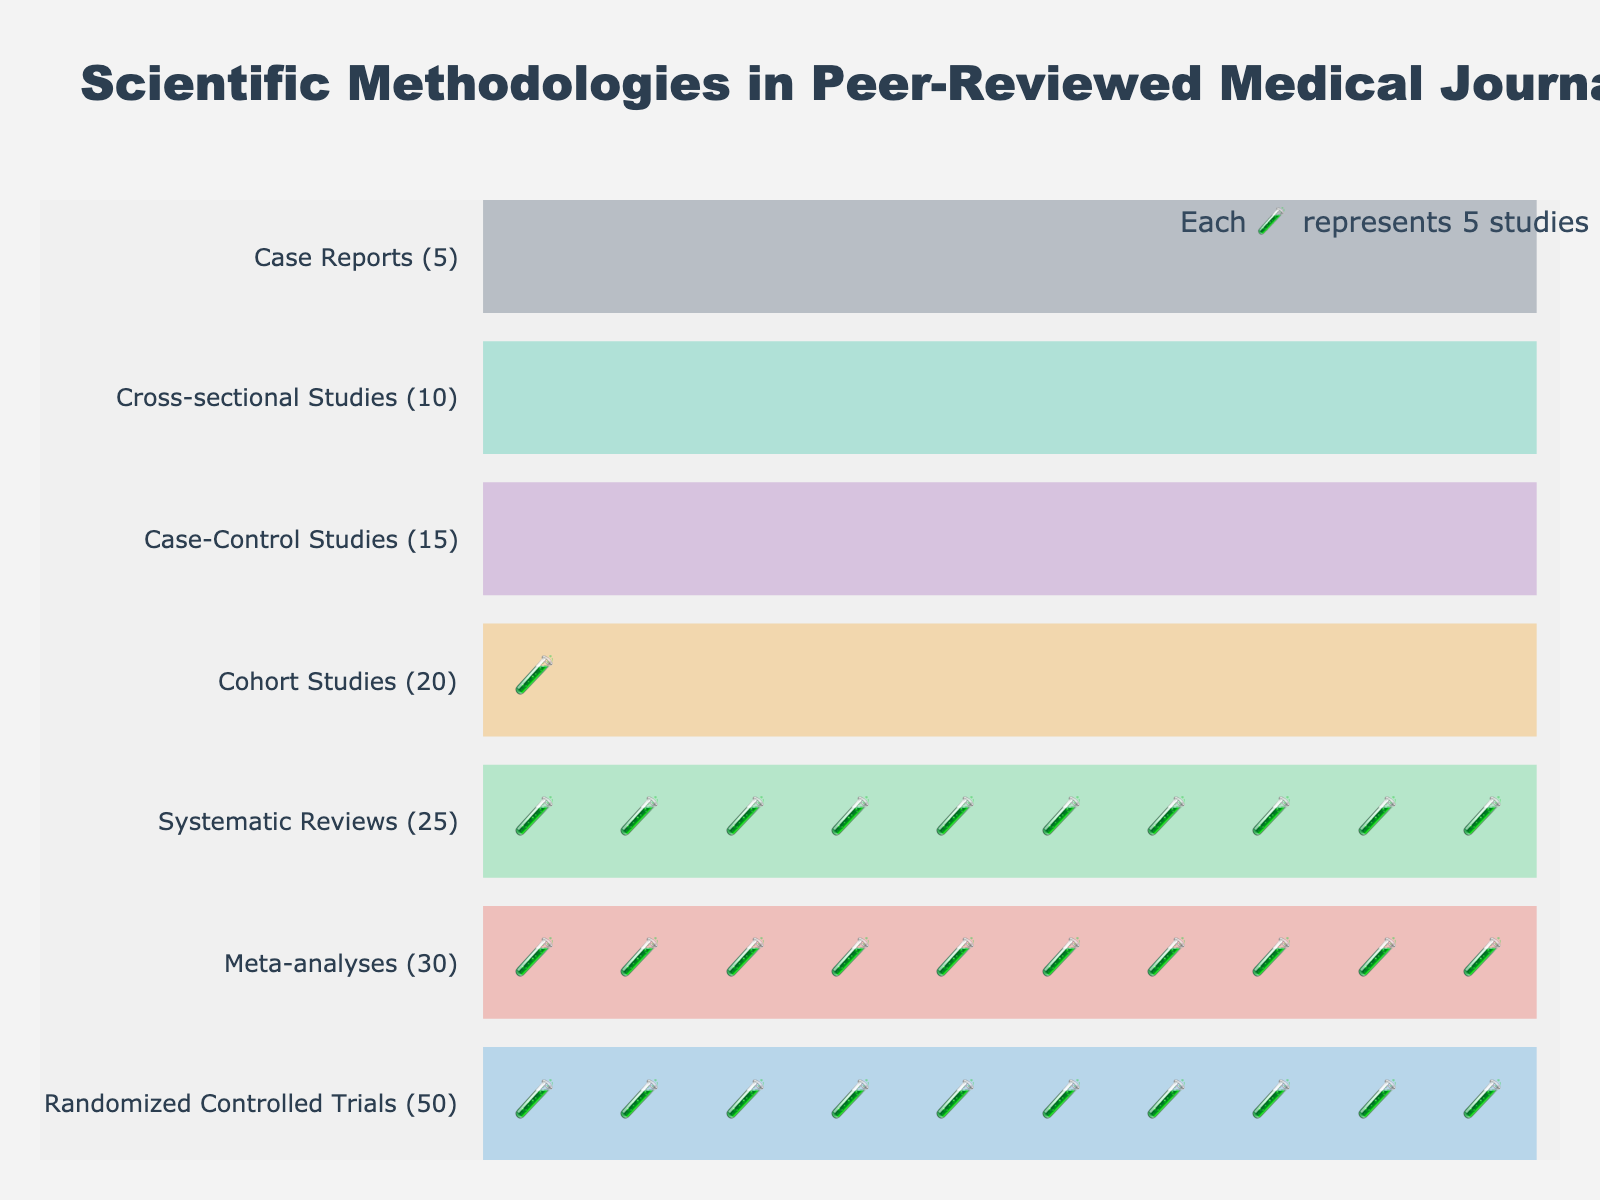Which methodology is represented by the most icons? The title indicates each icon represents 5 studies. Randomized Controlled Trials have the highest count of 50, which translates to 10 icons (50/5=10).
Answer: Randomized Controlled Trials What's the total number of studies represented in the plot? Sum all the counts: 50 + 30 + 25 + 20 + 15 + 10 + 5 = 155.
Answer: 155 Which methodology has exactly half the count of Randomized Controlled Trials? Randomized Controlled Trials have 50 studies, half of which is 25. Systematic Reviews have exactly 25 studies.
Answer: Systematic Reviews Which methodology is represented by the fewest icons? Case Reports have the lowest count of 5, translating to 1 icon (5/5=1).
Answer: Case Reports How many more studies do Meta-analyses have compared to Case-Control Studies? Meta-analyses have 30 studies, and Case-Control Studies have 15. The difference is 30 - 15 = 15.
Answer: 15 What's the combined total number of studies in Cohort Studies and Cross-sectional Studies? Cohort Studies have 20 and Cross-sectional Studies have 10. Combined, they total 20 + 10 = 30.
Answer: 30 Which methodologies have fewer than 20 studies, and how many of those are there? Case-Control Studies have 15, Cross-sectional Studies have 10, and Case Reports have 5. There are 3 methodologies with fewer than 20 studies.
Answer: 3 How many methodologies have a count greater than the median value of all study counts? The counts are 50, 30, 25, 20, 15, 10, and 5. The median is 20. The methodologies with counts greater than 20 are Randomized Controlled Trials, Meta-analyses, and Systematic Reviews (3 methodologies).
Answer: 3 Which methodologies fall into the second color band (orange)? The second color band corresponds to the area around the hover text for Meta-analyses. This corresponds to the methodology Meta-analyses.
Answer: Meta-analyses 